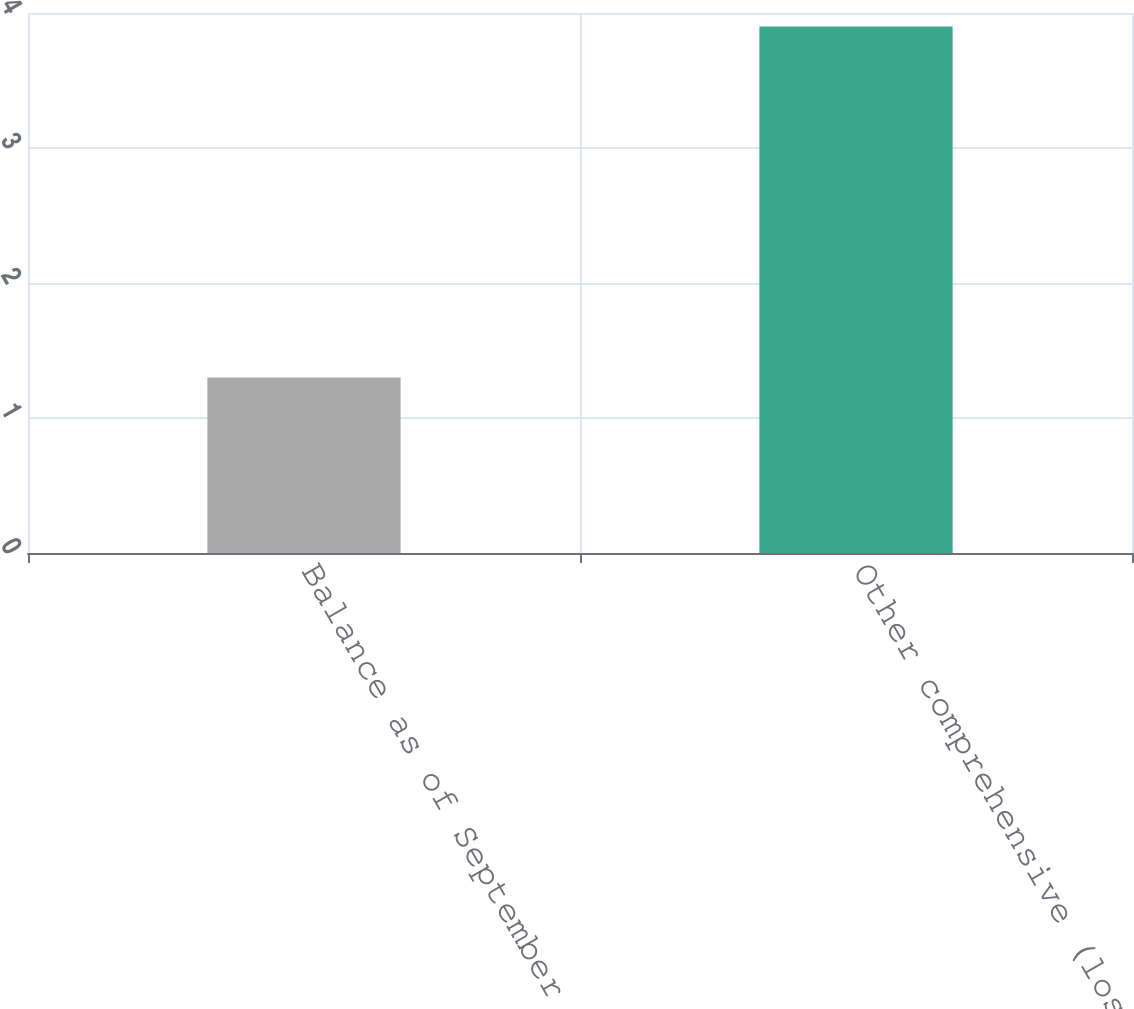<chart> <loc_0><loc_0><loc_500><loc_500><bar_chart><fcel>Balance as of September 30<fcel>Other comprehensive (loss)<nl><fcel>1.3<fcel>3.9<nl></chart> 